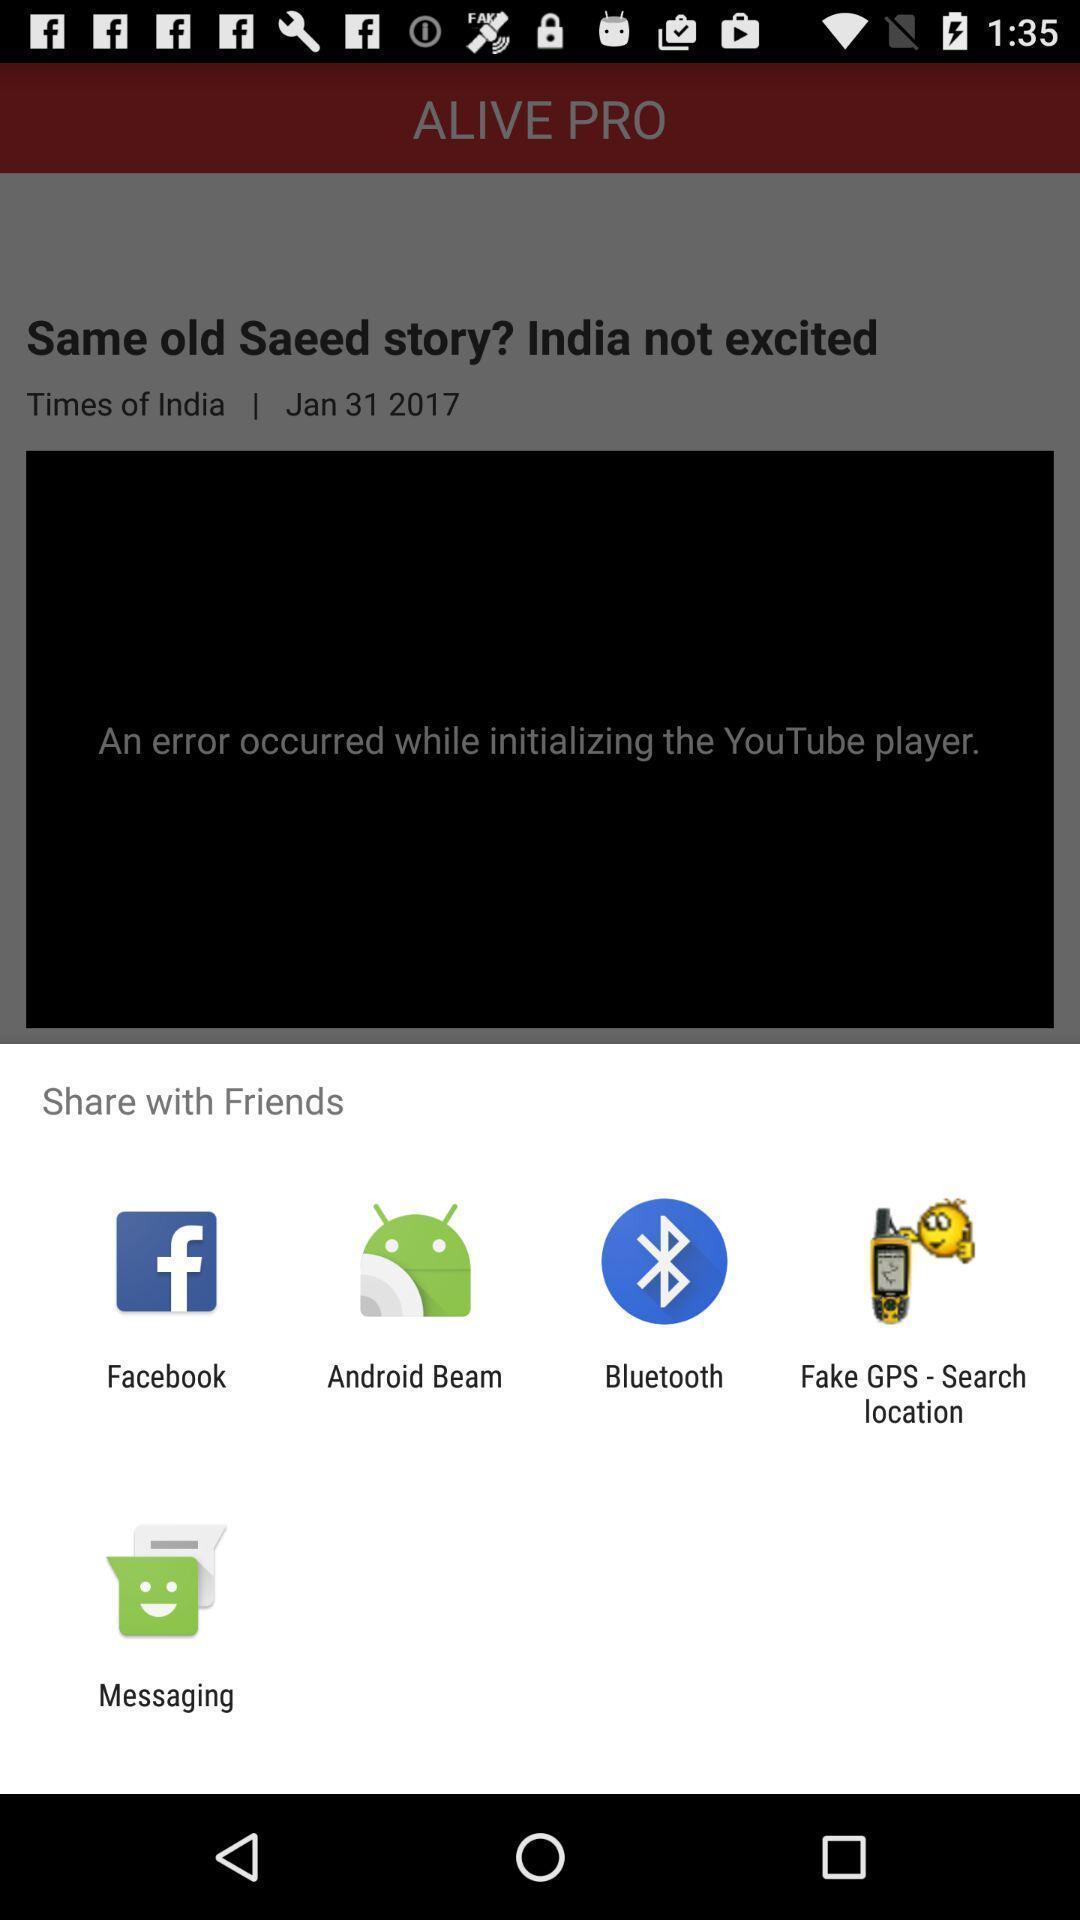Summarize the main components in this picture. Pop-up showing various share options. 